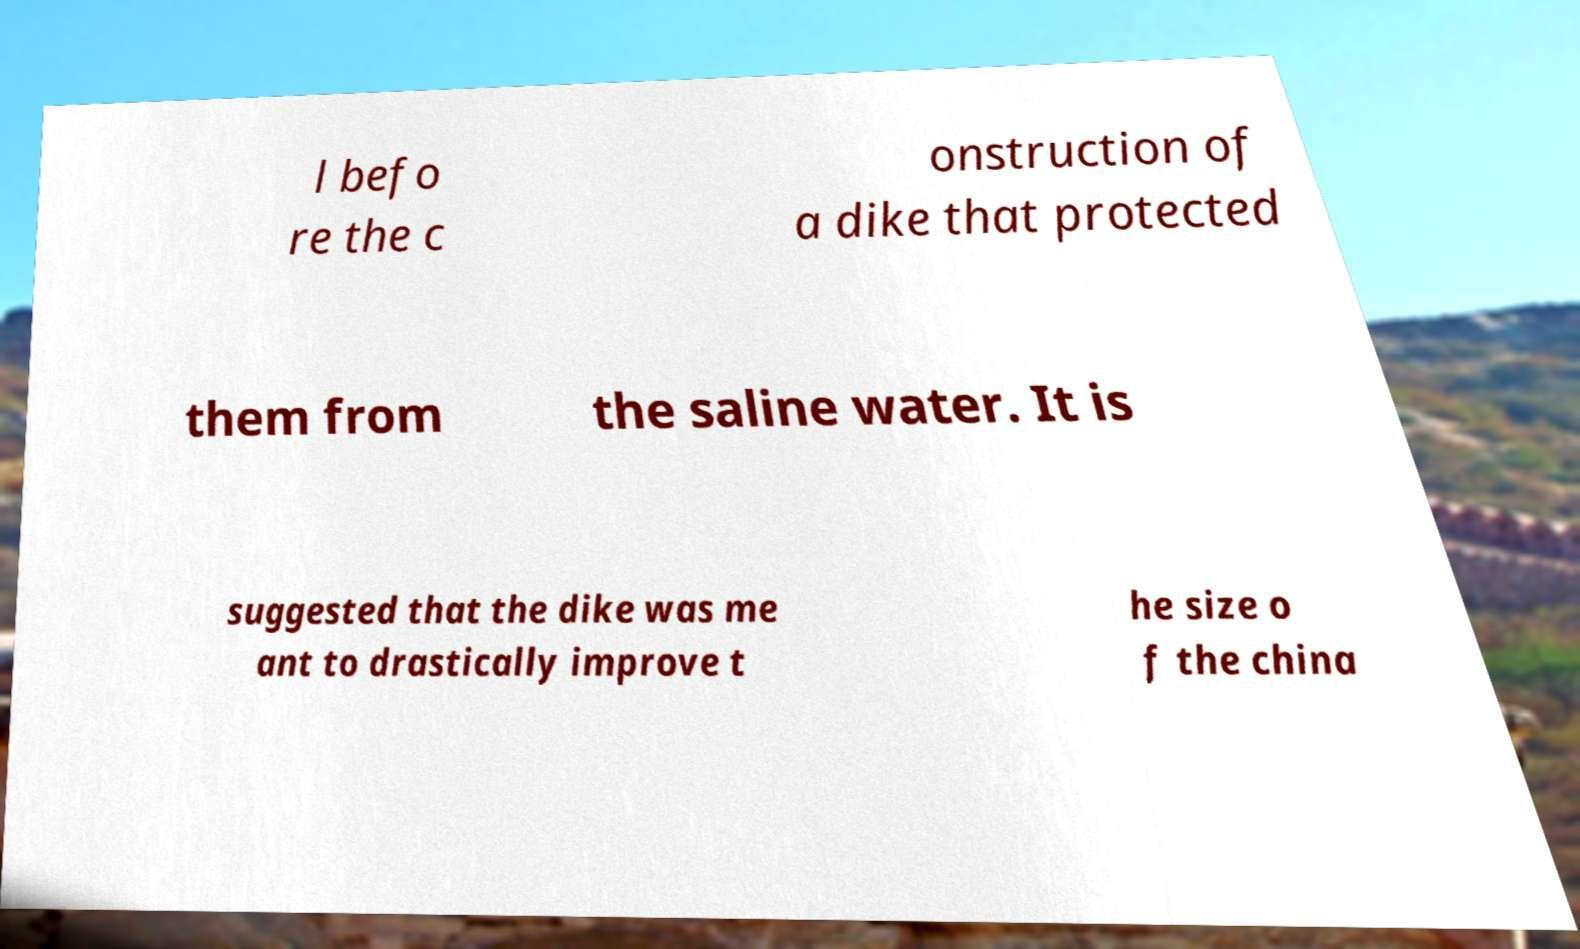Please identify and transcribe the text found in this image. l befo re the c onstruction of a dike that protected them from the saline water. It is suggested that the dike was me ant to drastically improve t he size o f the china 